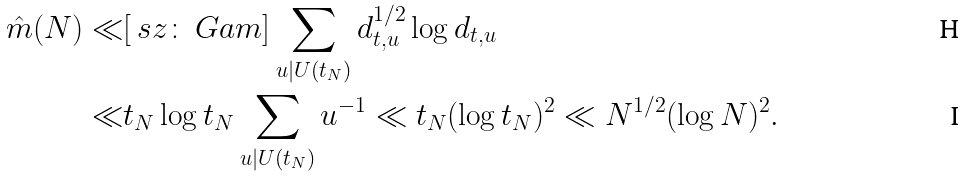Convert formula to latex. <formula><loc_0><loc_0><loc_500><loc_500>\hat { m } ( N ) \ll & [ \ s z \colon \ G a m ] \sum _ { u | U ( t _ { N } ) } d _ { t , u } ^ { 1 / 2 } \log { d _ { t , u } } \\ \ll & t _ { N } \log { t _ { N } } \sum _ { u | U ( t _ { N } ) } u ^ { - 1 } \ll t _ { N } ( \log { t _ { N } } ) ^ { 2 } \ll N ^ { 1 / 2 } ( \log { N } ) ^ { 2 } .</formula> 